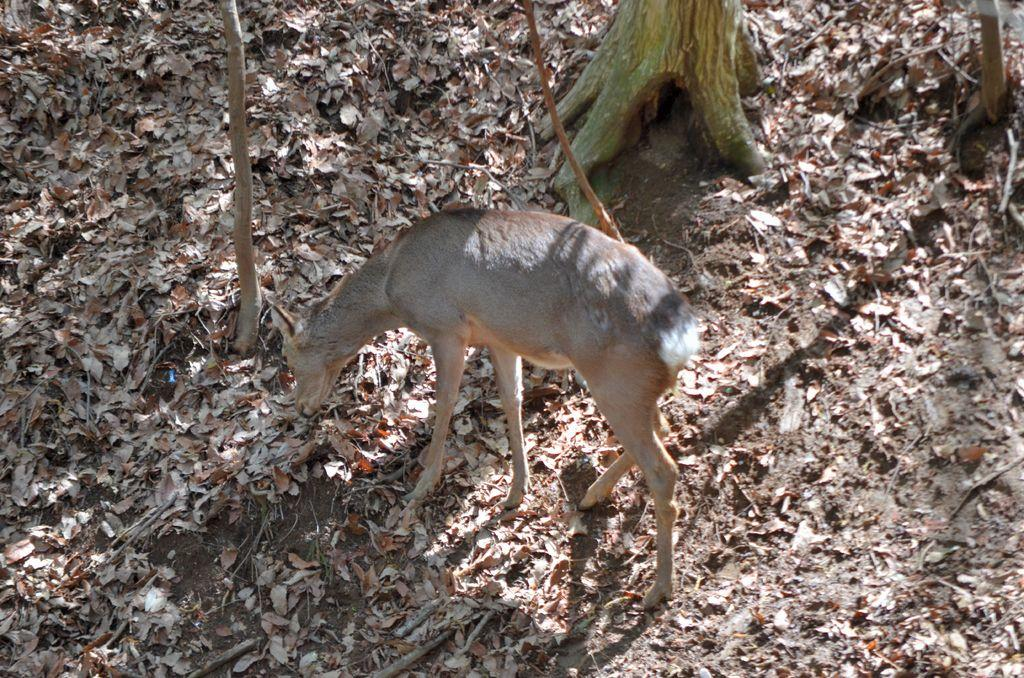What animal is present in the image? There is a deer in the image. What is the deer doing in the image? The deer is eating dry leaves. Where is the deer located in relation to the tree? The deer is standing beside a tree. What type of ink can be seen dripping from the deer's neck in the image? There is no ink or dripping substance visible on the deer's neck in the image. 